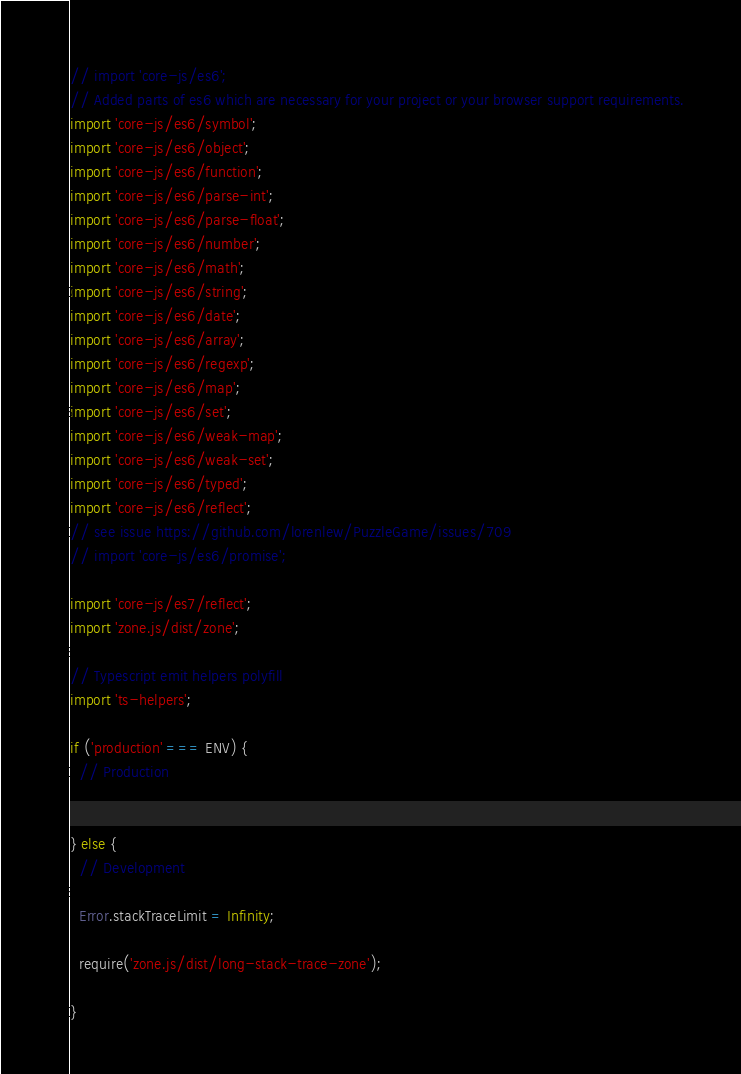Convert code to text. <code><loc_0><loc_0><loc_500><loc_500><_TypeScript_>// import 'core-js/es6';
// Added parts of es6 which are necessary for your project or your browser support requirements.
import 'core-js/es6/symbol';
import 'core-js/es6/object';
import 'core-js/es6/function';
import 'core-js/es6/parse-int';
import 'core-js/es6/parse-float';
import 'core-js/es6/number';
import 'core-js/es6/math';
import 'core-js/es6/string';
import 'core-js/es6/date';
import 'core-js/es6/array';
import 'core-js/es6/regexp';
import 'core-js/es6/map';
import 'core-js/es6/set';
import 'core-js/es6/weak-map';
import 'core-js/es6/weak-set';
import 'core-js/es6/typed';
import 'core-js/es6/reflect';
// see issue https://github.com/lorenlew/PuzzleGame/issues/709
// import 'core-js/es6/promise';

import 'core-js/es7/reflect';
import 'zone.js/dist/zone';

// Typescript emit helpers polyfill
import 'ts-helpers';

if ('production' === ENV) {
  // Production


} else {
  // Development

  Error.stackTraceLimit = Infinity;

  require('zone.js/dist/long-stack-trace-zone');

}
</code> 